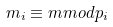Convert formula to latex. <formula><loc_0><loc_0><loc_500><loc_500>m _ { i } \equiv m m o d p _ { i }</formula> 